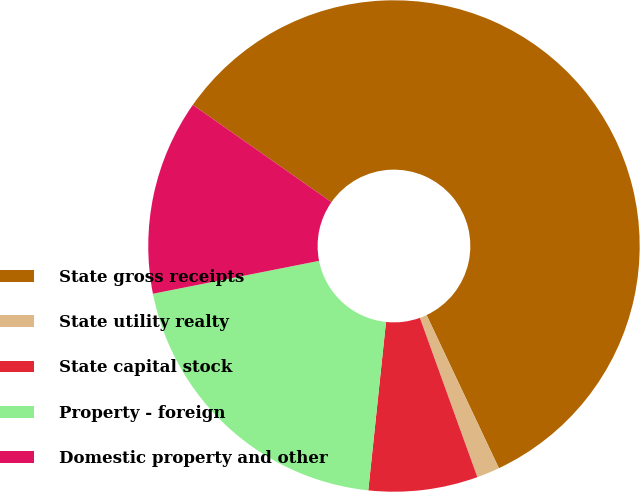Convert chart. <chart><loc_0><loc_0><loc_500><loc_500><pie_chart><fcel>State gross receipts<fcel>State utility realty<fcel>State capital stock<fcel>Property - foreign<fcel>Domestic property and other<nl><fcel>58.24%<fcel>1.51%<fcel>7.18%<fcel>20.22%<fcel>12.85%<nl></chart> 